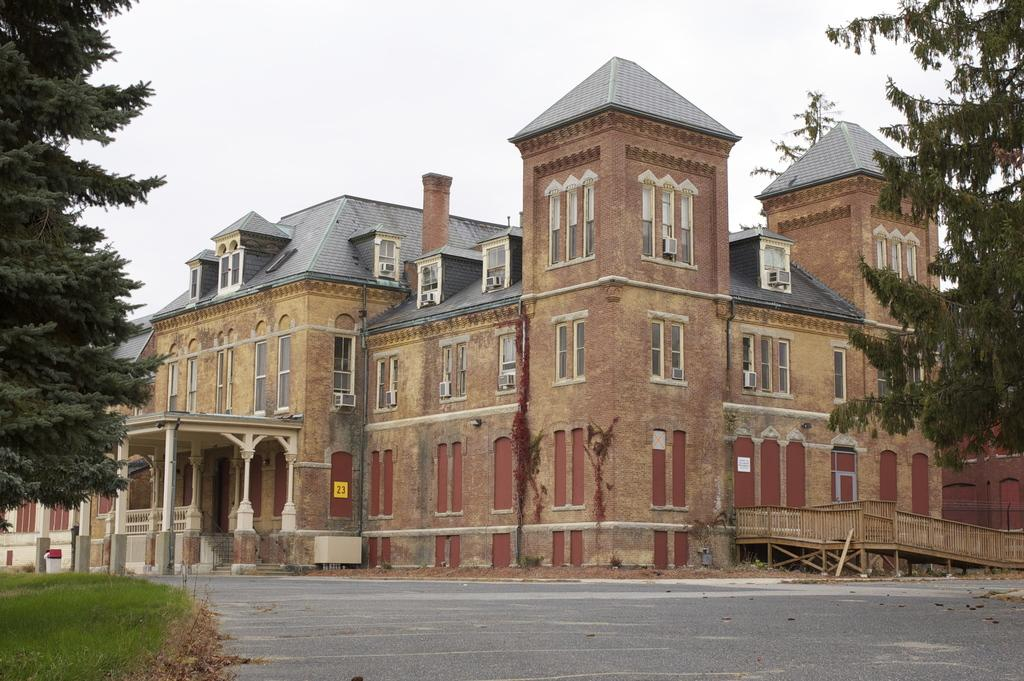What is in the foreground of the image? There is a road in the foreground of the image. What can be seen behind the road? There is an architecture behind the road. What type of vegetation is present around the architecture? Grass is present around the architecture, and trees are visible around it as well. What type of ball can be seen rolling through the garden in the image? There is no garden or ball present in the image. 